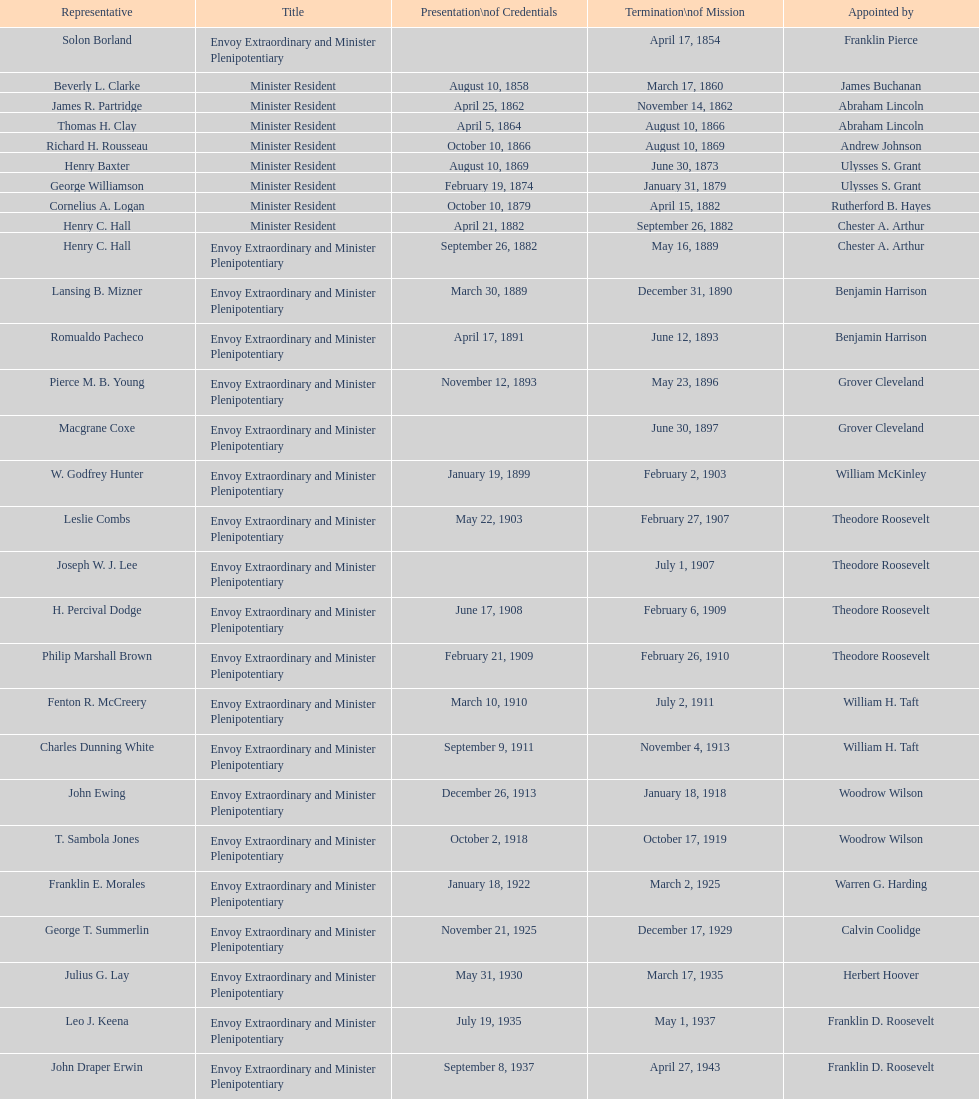Who became the ambassador after the completion of hewson ryan's mission? Phillip V. Sanchez. 